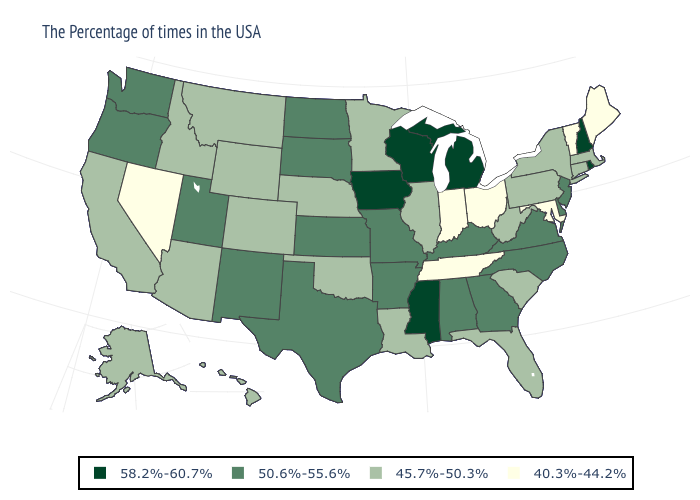What is the value of New York?
Be succinct. 45.7%-50.3%. What is the value of New Mexico?
Keep it brief. 50.6%-55.6%. Name the states that have a value in the range 58.2%-60.7%?
Short answer required. Rhode Island, New Hampshire, Michigan, Wisconsin, Mississippi, Iowa. Name the states that have a value in the range 58.2%-60.7%?
Quick response, please. Rhode Island, New Hampshire, Michigan, Wisconsin, Mississippi, Iowa. Does Tennessee have the lowest value in the USA?
Answer briefly. Yes. Is the legend a continuous bar?
Be succinct. No. Does Alaska have a higher value than Vermont?
Be succinct. Yes. Name the states that have a value in the range 58.2%-60.7%?
Answer briefly. Rhode Island, New Hampshire, Michigan, Wisconsin, Mississippi, Iowa. Which states have the lowest value in the South?
Write a very short answer. Maryland, Tennessee. Does the map have missing data?
Be succinct. No. Does North Dakota have the same value as California?
Short answer required. No. What is the value of Wisconsin?
Concise answer only. 58.2%-60.7%. Name the states that have a value in the range 45.7%-50.3%?
Answer briefly. Massachusetts, Connecticut, New York, Pennsylvania, South Carolina, West Virginia, Florida, Illinois, Louisiana, Minnesota, Nebraska, Oklahoma, Wyoming, Colorado, Montana, Arizona, Idaho, California, Alaska, Hawaii. Among the states that border Connecticut , which have the lowest value?
Answer briefly. Massachusetts, New York. What is the value of Texas?
Be succinct. 50.6%-55.6%. 